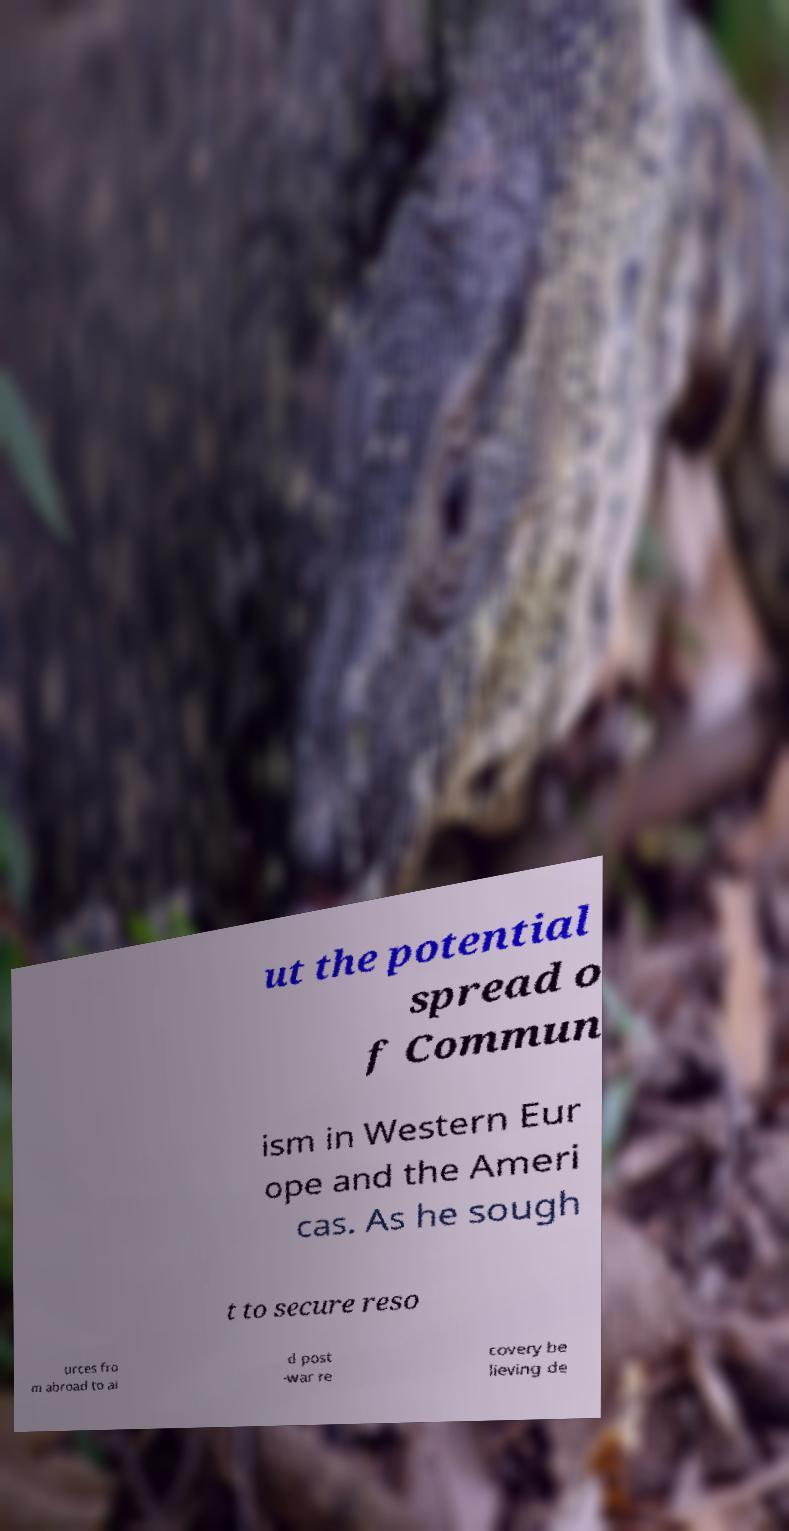Can you accurately transcribe the text from the provided image for me? ut the potential spread o f Commun ism in Western Eur ope and the Ameri cas. As he sough t to secure reso urces fro m abroad to ai d post -war re covery be lieving de 